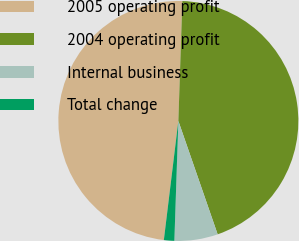<chart> <loc_0><loc_0><loc_500><loc_500><pie_chart><fcel>2005 operating profit<fcel>2004 operating profit<fcel>Internal business<fcel>Total change<nl><fcel>48.6%<fcel>44.16%<fcel>5.84%<fcel>1.4%<nl></chart> 